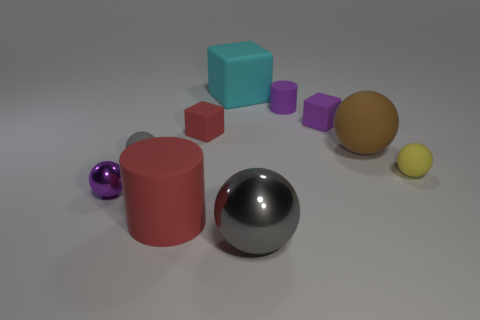What number of tiny objects are either cyan objects or purple metallic things?
Your response must be concise. 1. Are there any red blocks that have the same size as the yellow sphere?
Make the answer very short. Yes. What number of metallic things are either large cylinders or small purple cylinders?
Your response must be concise. 0. What is the shape of the small rubber thing that is the same color as the large metal sphere?
Keep it short and to the point. Sphere. What number of big gray blocks are there?
Your answer should be very brief. 0. Does the tiny sphere that is on the right side of the tiny purple matte cube have the same material as the cylinder to the right of the large gray object?
Offer a very short reply. Yes. The yellow thing that is made of the same material as the cyan cube is what size?
Make the answer very short. Small. There is a small purple object in front of the red cube; what is its shape?
Provide a short and direct response. Sphere. Do the tiny matte sphere behind the tiny yellow matte object and the cube behind the small purple block have the same color?
Provide a succinct answer. No. There is a matte cube that is the same color as the large matte cylinder; what size is it?
Offer a very short reply. Small. 